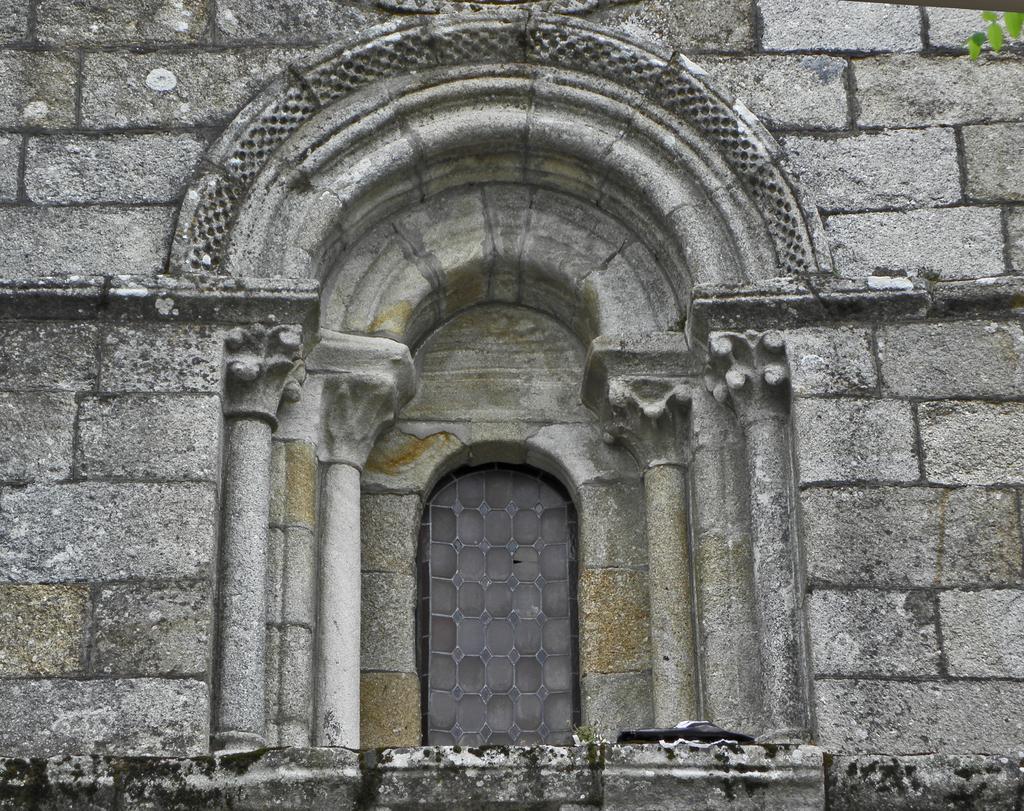In one or two sentences, can you explain what this image depicts? In this picture there is a wall and in the center there is a window. On the top right there are leaves. 